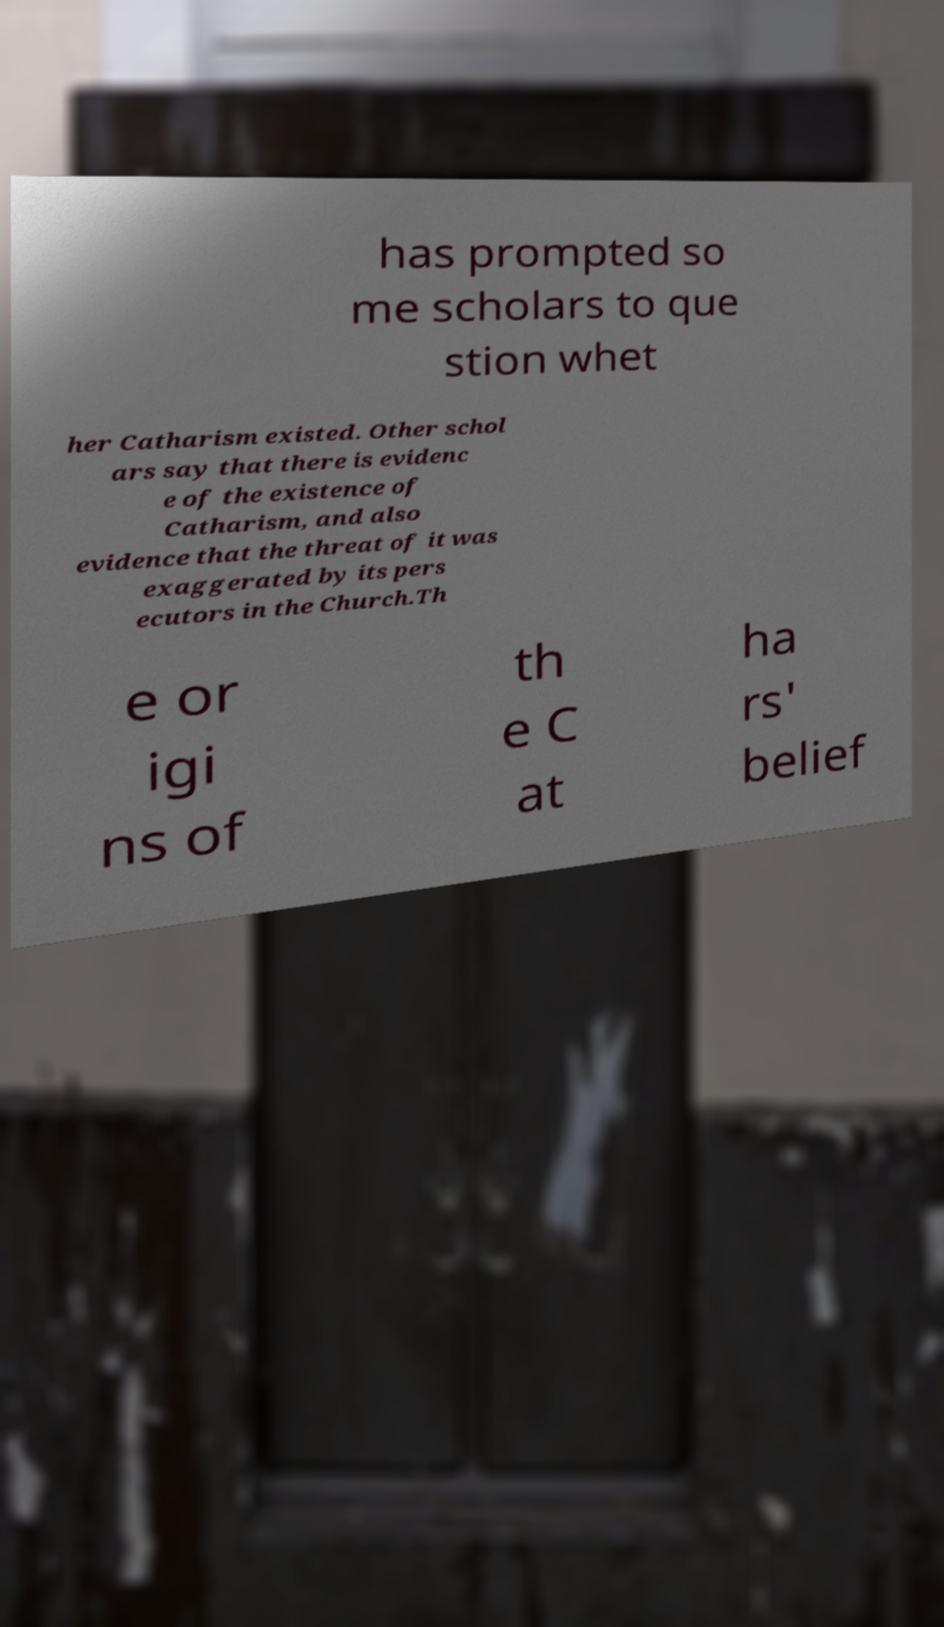Could you assist in decoding the text presented in this image and type it out clearly? has prompted so me scholars to que stion whet her Catharism existed. Other schol ars say that there is evidenc e of the existence of Catharism, and also evidence that the threat of it was exaggerated by its pers ecutors in the Church.Th e or igi ns of th e C at ha rs' belief 